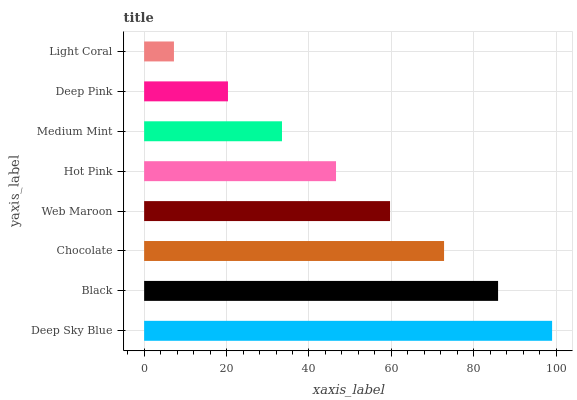Is Light Coral the minimum?
Answer yes or no. Yes. Is Deep Sky Blue the maximum?
Answer yes or no. Yes. Is Black the minimum?
Answer yes or no. No. Is Black the maximum?
Answer yes or no. No. Is Deep Sky Blue greater than Black?
Answer yes or no. Yes. Is Black less than Deep Sky Blue?
Answer yes or no. Yes. Is Black greater than Deep Sky Blue?
Answer yes or no. No. Is Deep Sky Blue less than Black?
Answer yes or no. No. Is Web Maroon the high median?
Answer yes or no. Yes. Is Hot Pink the low median?
Answer yes or no. Yes. Is Medium Mint the high median?
Answer yes or no. No. Is Black the low median?
Answer yes or no. No. 